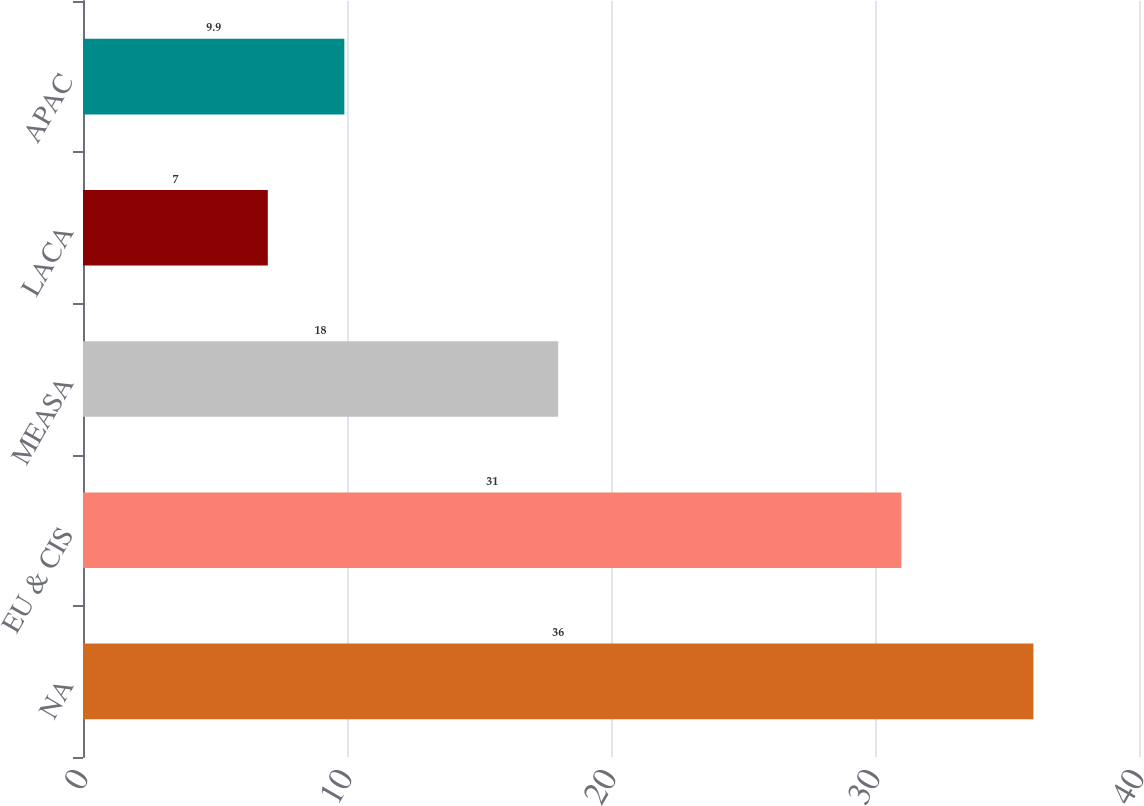Convert chart. <chart><loc_0><loc_0><loc_500><loc_500><bar_chart><fcel>NA<fcel>EU & CIS<fcel>MEASA<fcel>LACA<fcel>APAC<nl><fcel>36<fcel>31<fcel>18<fcel>7<fcel>9.9<nl></chart> 